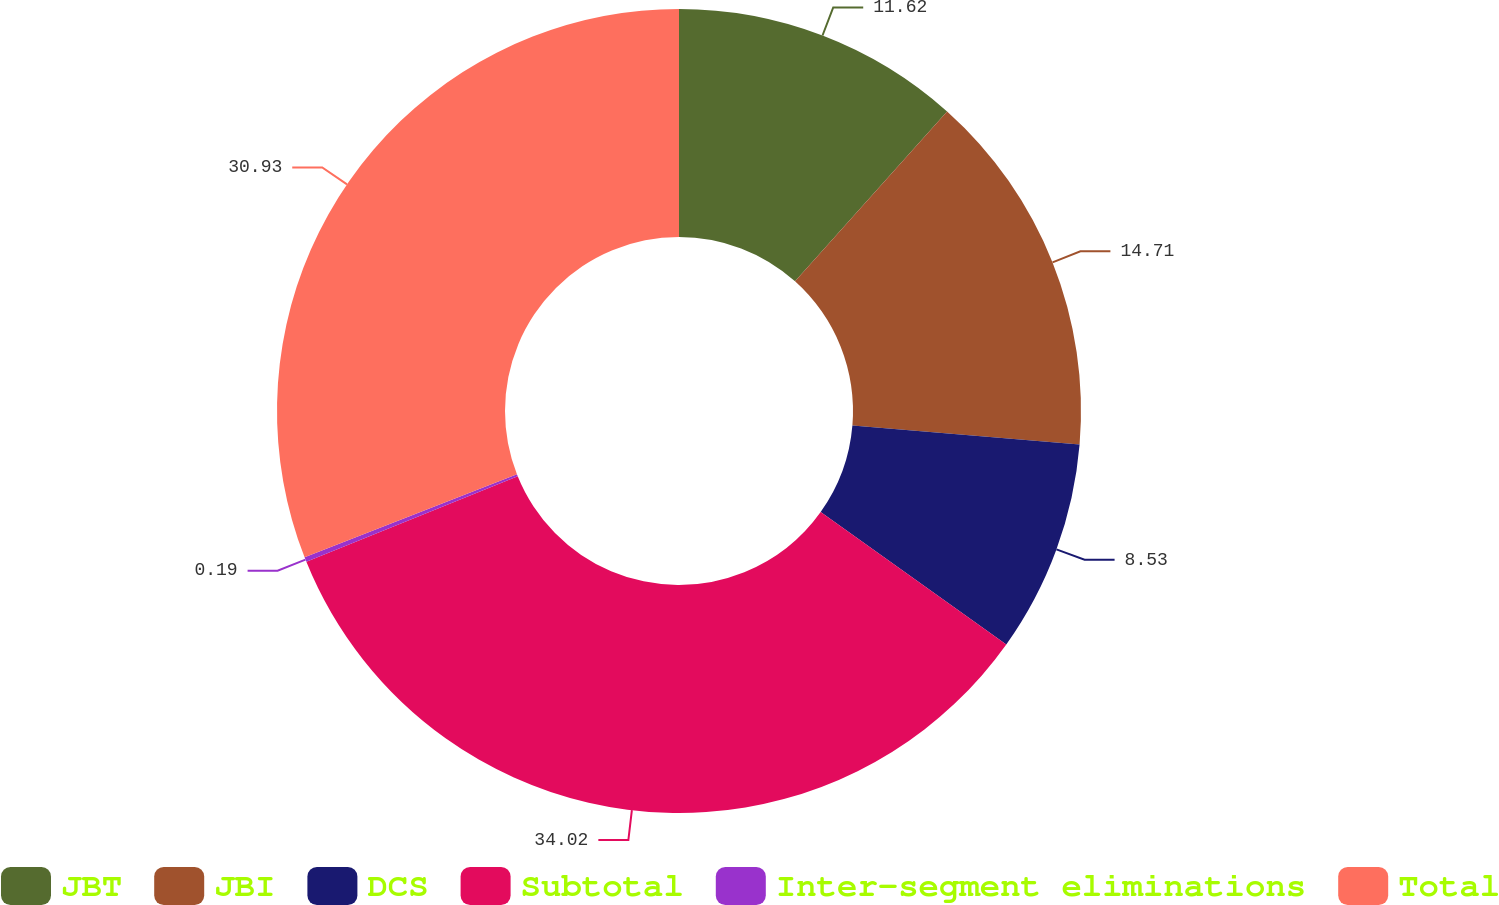<chart> <loc_0><loc_0><loc_500><loc_500><pie_chart><fcel>JBT<fcel>JBI<fcel>DCS<fcel>Subtotal<fcel>Inter-segment eliminations<fcel>Total<nl><fcel>11.62%<fcel>14.71%<fcel>8.53%<fcel>34.02%<fcel>0.19%<fcel>30.93%<nl></chart> 